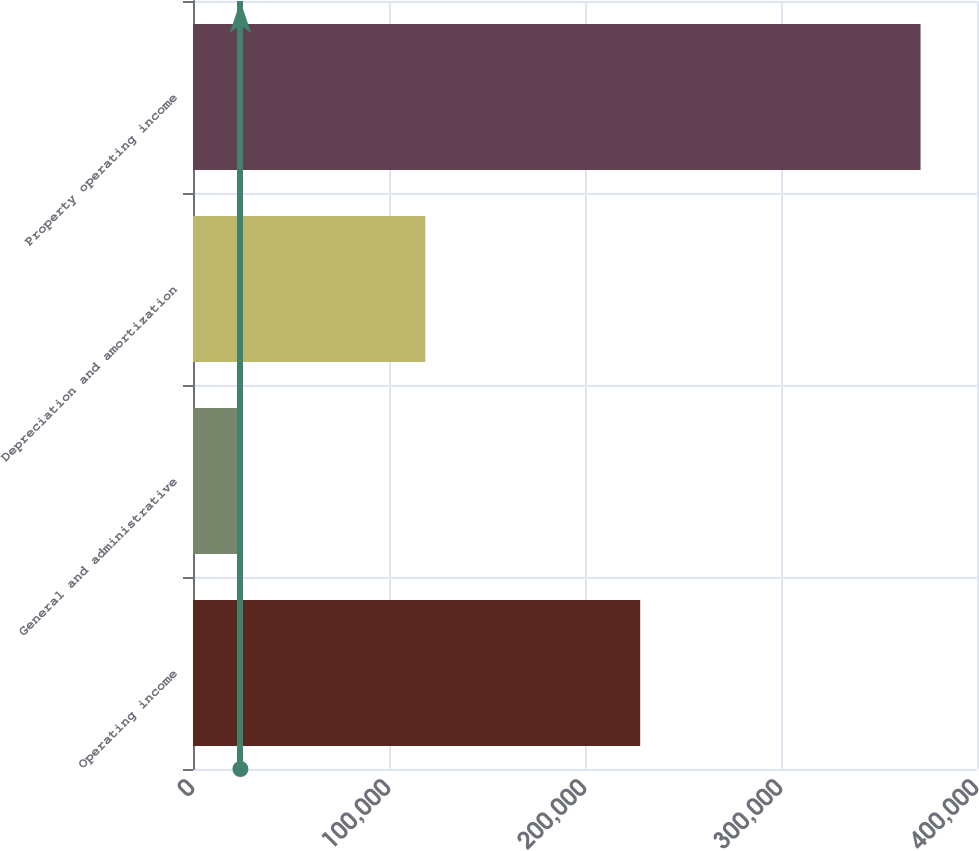Convert chart to OTSL. <chart><loc_0><loc_0><loc_500><loc_500><bar_chart><fcel>Operating income<fcel>General and administrative<fcel>Depreciation and amortization<fcel>Property operating income<nl><fcel>228145<fcel>24189<fcel>118534<fcel>371198<nl></chart> 